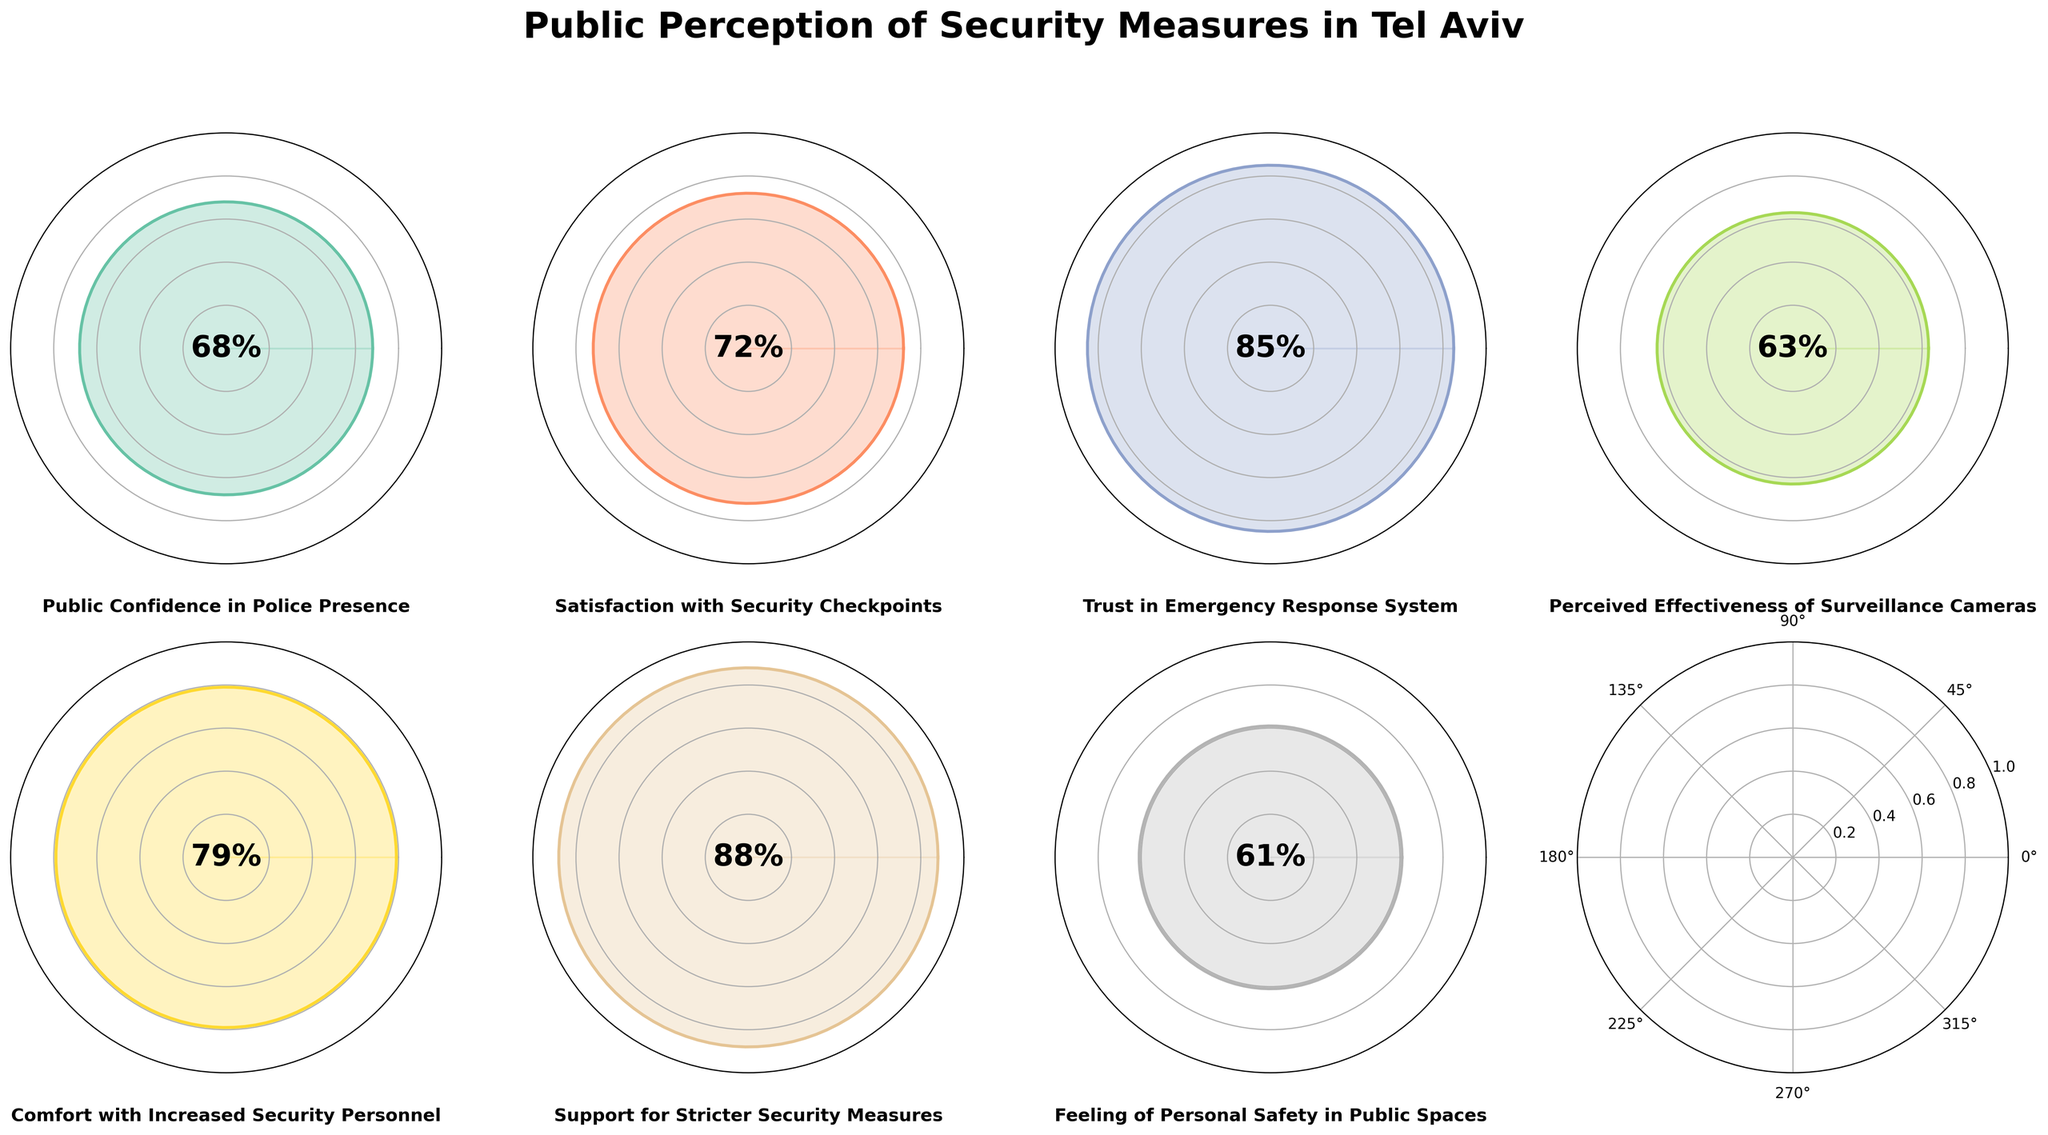Which category has the highest public perception value? To determine the category with the highest value, look at all the gauge charts and find the one with the highest percentage. The highest value is for "Support for Stricter Security Measures" at 88%.
Answer: Support for Stricter Security Measures What is the average public perception value across all categories? Add all the values together and divide by the number of categories. (68+72+85+63+79+88+61)/7 = 516/7 ≈ 73.71
Answer: 73.71 Which category has the lowest public perception value? To find the lowest value, look at all the gauge charts and find the one with the smallest percentage. The lowest value is for "Feeling of Personal Safety in Public Spaces" at 61%.
Answer: Feeling of Personal Safety in Public Spaces How many categories have public perception values above 80%? Identify and count the categories where the values are greater than 80. Only "Trust in Emergency Response System" (85%) and "Support for Stricter Security Measures" (88%) are above 80.
Answer: 2 Which categories have public perception values between 60% and 70%? Identify the categories whose values fall within the specified range. "Public Confidence in Police Presence" (68%) and "Feeling of Personal Safety in Public Spaces" (61%) fit this range.
Answer: Public Confidence in Police Presence, Feeling of Personal Safety in Public Spaces Is the public more satisfied with security checkpoints or with surveillance cameras? Compare the values for "Satisfaction with Security Checkpoints" (72%) and "Perceived Effectiveness of Surveillance Cameras" (63%). The public is more satisfied with security checkpoints.
Answer: Satisfaction with Security Checkpoints What is the median value of the public perception categories? Organize the values in numerical order and find the middle one. Ordered values: 61, 63, 68, 72, 79, 85, 88. The median is the 4th value, which is 72.
Answer: 72 By how much does the public perception of "Trust in Emergency Response System" exceed that of "Perceived Effectiveness of Surveillance Cameras"? Subtract the value of "Perceived Effectiveness of Surveillance Cameras" (63%) from "Trust in Emergency Response System" (85%). 85 - 63 = 22
Answer: 22 Which category do people feel most comfortable with, and what is its value? Look at the values and find the highest one. The category "Support for Stricter Security Measures" has the highest value, which is 88%.
Answer: Support for Stricter Security Measures, 88% 